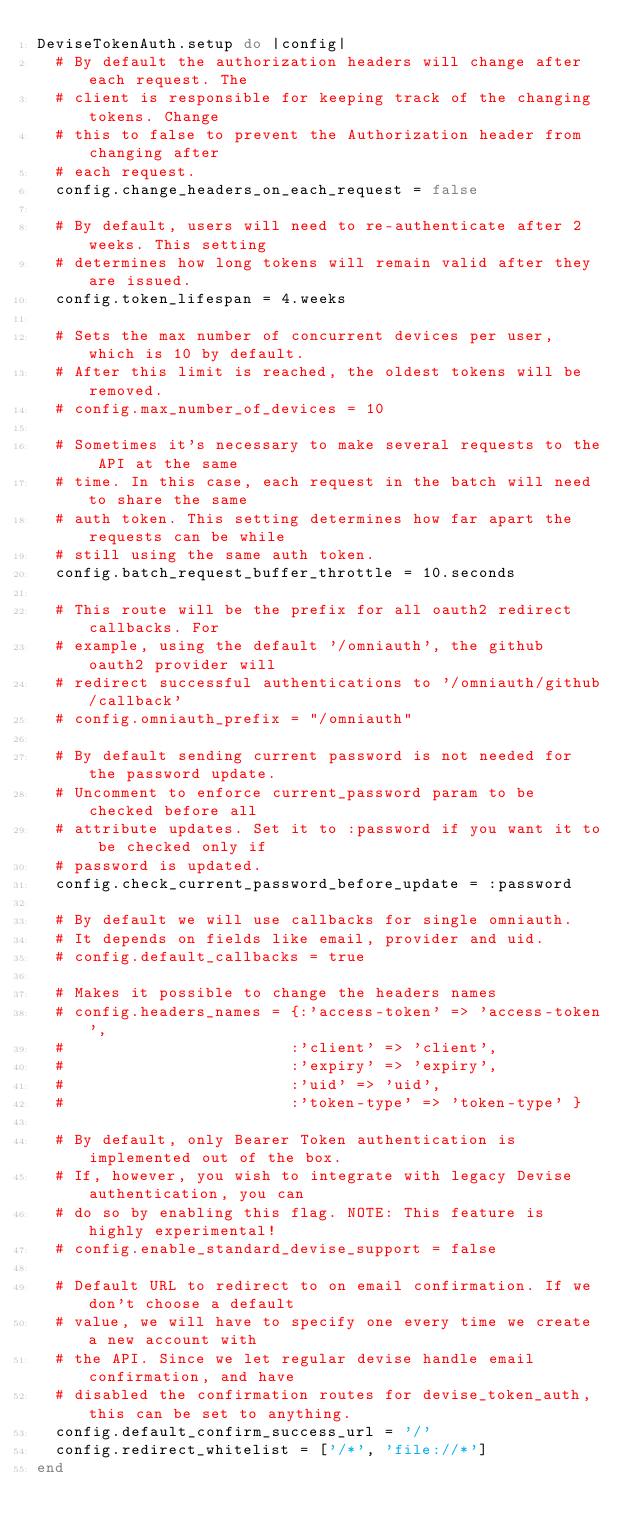Convert code to text. <code><loc_0><loc_0><loc_500><loc_500><_Ruby_>DeviseTokenAuth.setup do |config|
  # By default the authorization headers will change after each request. The
  # client is responsible for keeping track of the changing tokens. Change
  # this to false to prevent the Authorization header from changing after
  # each request.
  config.change_headers_on_each_request = false

  # By default, users will need to re-authenticate after 2 weeks. This setting
  # determines how long tokens will remain valid after they are issued.
  config.token_lifespan = 4.weeks

  # Sets the max number of concurrent devices per user, which is 10 by default.
  # After this limit is reached, the oldest tokens will be removed.
  # config.max_number_of_devices = 10

  # Sometimes it's necessary to make several requests to the API at the same
  # time. In this case, each request in the batch will need to share the same
  # auth token. This setting determines how far apart the requests can be while
  # still using the same auth token.
  config.batch_request_buffer_throttle = 10.seconds

  # This route will be the prefix for all oauth2 redirect callbacks. For
  # example, using the default '/omniauth', the github oauth2 provider will
  # redirect successful authentications to '/omniauth/github/callback'
  # config.omniauth_prefix = "/omniauth"

  # By default sending current password is not needed for the password update.
  # Uncomment to enforce current_password param to be checked before all
  # attribute updates. Set it to :password if you want it to be checked only if
  # password is updated.
  config.check_current_password_before_update = :password

  # By default we will use callbacks for single omniauth.
  # It depends on fields like email, provider and uid.
  # config.default_callbacks = true

  # Makes it possible to change the headers names
  # config.headers_names = {:'access-token' => 'access-token',
  #                        :'client' => 'client',
  #                        :'expiry' => 'expiry',
  #                        :'uid' => 'uid',
  #                        :'token-type' => 'token-type' }

  # By default, only Bearer Token authentication is implemented out of the box.
  # If, however, you wish to integrate with legacy Devise authentication, you can
  # do so by enabling this flag. NOTE: This feature is highly experimental!
  # config.enable_standard_devise_support = false

  # Default URL to redirect to on email confirmation. If we don't choose a default
  # value, we will have to specify one every time we create a new account with
  # the API. Since we let regular devise handle email confirmation, and have
  # disabled the confirmation routes for devise_token_auth, this can be set to anything.
  config.default_confirm_success_url = '/'
  config.redirect_whitelist = ['/*', 'file://*']
end
</code> 